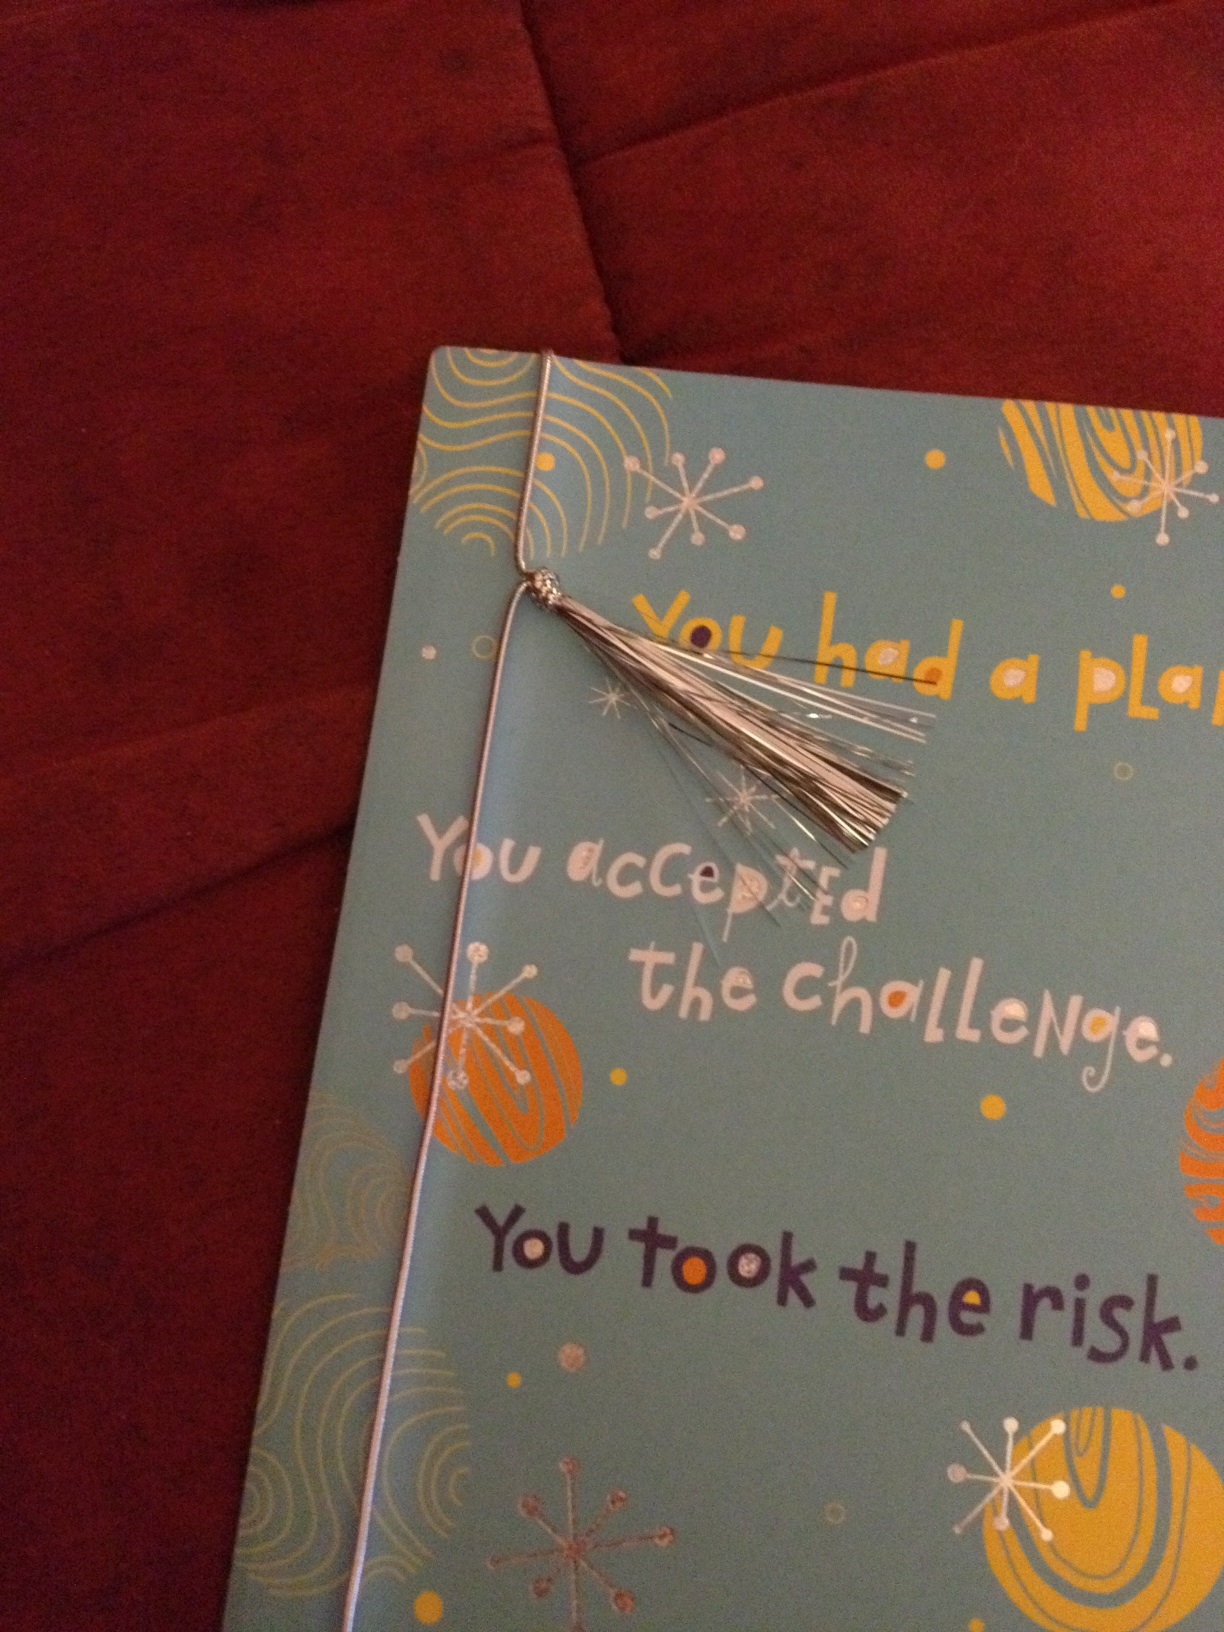What is on this card? The card features a motivational message that says, 'You had a plan. You accepted the challenge. You took the risk.' The card is also adorned with colorful abstract designs and a silver tassel decoration. 